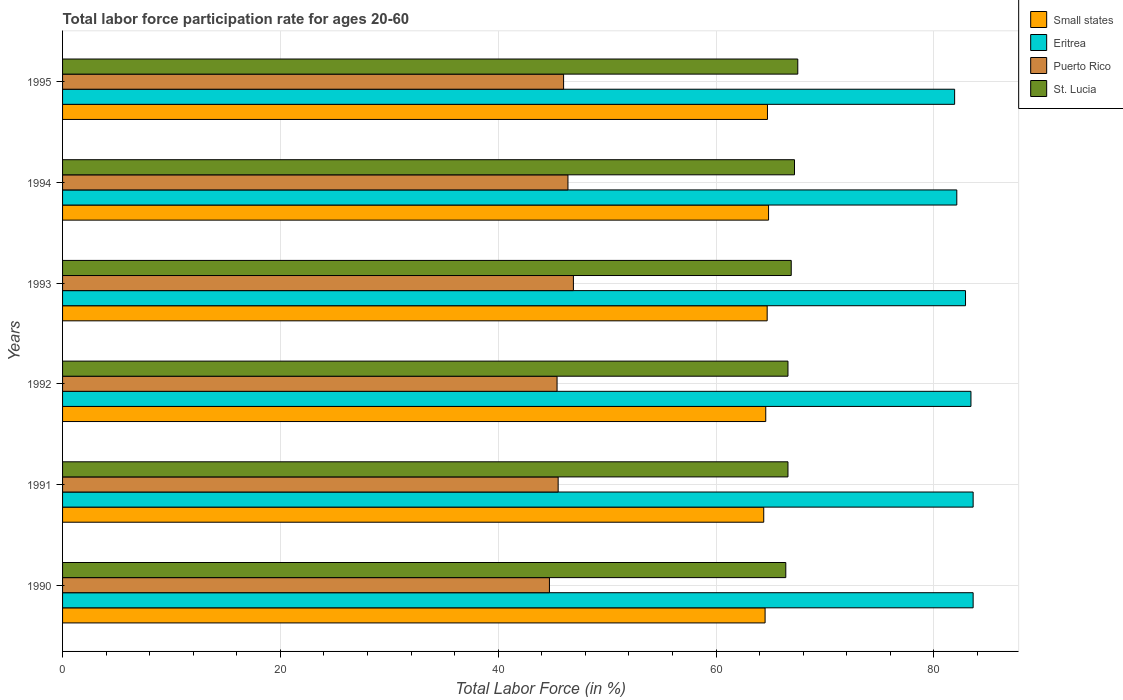How many different coloured bars are there?
Ensure brevity in your answer.  4. How many bars are there on the 4th tick from the top?
Provide a short and direct response. 4. In how many cases, is the number of bars for a given year not equal to the number of legend labels?
Provide a short and direct response. 0. What is the labor force participation rate in St. Lucia in 1993?
Ensure brevity in your answer.  66.9. Across all years, what is the maximum labor force participation rate in Puerto Rico?
Make the answer very short. 46.9. Across all years, what is the minimum labor force participation rate in Eritrea?
Offer a very short reply. 81.9. In which year was the labor force participation rate in St. Lucia maximum?
Your response must be concise. 1995. What is the total labor force participation rate in Puerto Rico in the graph?
Provide a succinct answer. 274.9. What is the difference between the labor force participation rate in Puerto Rico in 1993 and that in 1995?
Provide a short and direct response. 0.9. What is the difference between the labor force participation rate in Puerto Rico in 1993 and the labor force participation rate in Eritrea in 1994?
Your response must be concise. -35.2. What is the average labor force participation rate in Eritrea per year?
Make the answer very short. 82.92. In the year 1990, what is the difference between the labor force participation rate in St. Lucia and labor force participation rate in Puerto Rico?
Provide a short and direct response. 21.7. What is the ratio of the labor force participation rate in Puerto Rico in 1990 to that in 1995?
Offer a very short reply. 0.97. Is the labor force participation rate in Small states in 1991 less than that in 1993?
Offer a terse response. Yes. What is the difference between the highest and the lowest labor force participation rate in Eritrea?
Provide a short and direct response. 1.7. In how many years, is the labor force participation rate in Eritrea greater than the average labor force participation rate in Eritrea taken over all years?
Offer a very short reply. 3. Is the sum of the labor force participation rate in Puerto Rico in 1990 and 1994 greater than the maximum labor force participation rate in St. Lucia across all years?
Provide a succinct answer. Yes. What does the 4th bar from the top in 1995 represents?
Your answer should be compact. Small states. What does the 1st bar from the bottom in 1991 represents?
Give a very brief answer. Small states. Is it the case that in every year, the sum of the labor force participation rate in Small states and labor force participation rate in Eritrea is greater than the labor force participation rate in St. Lucia?
Make the answer very short. Yes. Are all the bars in the graph horizontal?
Ensure brevity in your answer.  Yes. How many years are there in the graph?
Offer a very short reply. 6. Are the values on the major ticks of X-axis written in scientific E-notation?
Offer a terse response. No. Does the graph contain any zero values?
Ensure brevity in your answer.  No. Does the graph contain grids?
Give a very brief answer. Yes. How are the legend labels stacked?
Your response must be concise. Vertical. What is the title of the graph?
Your answer should be compact. Total labor force participation rate for ages 20-60. What is the Total Labor Force (in %) of Small states in 1990?
Keep it short and to the point. 64.5. What is the Total Labor Force (in %) of Eritrea in 1990?
Provide a succinct answer. 83.6. What is the Total Labor Force (in %) in Puerto Rico in 1990?
Offer a very short reply. 44.7. What is the Total Labor Force (in %) in St. Lucia in 1990?
Offer a terse response. 66.4. What is the Total Labor Force (in %) in Small states in 1991?
Provide a succinct answer. 64.37. What is the Total Labor Force (in %) of Eritrea in 1991?
Your response must be concise. 83.6. What is the Total Labor Force (in %) in Puerto Rico in 1991?
Provide a succinct answer. 45.5. What is the Total Labor Force (in %) in St. Lucia in 1991?
Provide a short and direct response. 66.6. What is the Total Labor Force (in %) of Small states in 1992?
Give a very brief answer. 64.56. What is the Total Labor Force (in %) of Eritrea in 1992?
Give a very brief answer. 83.4. What is the Total Labor Force (in %) of Puerto Rico in 1992?
Offer a very short reply. 45.4. What is the Total Labor Force (in %) of St. Lucia in 1992?
Your answer should be compact. 66.6. What is the Total Labor Force (in %) of Small states in 1993?
Keep it short and to the point. 64.69. What is the Total Labor Force (in %) of Eritrea in 1993?
Ensure brevity in your answer.  82.9. What is the Total Labor Force (in %) in Puerto Rico in 1993?
Your response must be concise. 46.9. What is the Total Labor Force (in %) in St. Lucia in 1993?
Make the answer very short. 66.9. What is the Total Labor Force (in %) in Small states in 1994?
Give a very brief answer. 64.82. What is the Total Labor Force (in %) in Eritrea in 1994?
Make the answer very short. 82.1. What is the Total Labor Force (in %) in Puerto Rico in 1994?
Your response must be concise. 46.4. What is the Total Labor Force (in %) of St. Lucia in 1994?
Your answer should be compact. 67.2. What is the Total Labor Force (in %) in Small states in 1995?
Keep it short and to the point. 64.72. What is the Total Labor Force (in %) in Eritrea in 1995?
Keep it short and to the point. 81.9. What is the Total Labor Force (in %) in St. Lucia in 1995?
Offer a terse response. 67.5. Across all years, what is the maximum Total Labor Force (in %) in Small states?
Make the answer very short. 64.82. Across all years, what is the maximum Total Labor Force (in %) in Eritrea?
Keep it short and to the point. 83.6. Across all years, what is the maximum Total Labor Force (in %) in Puerto Rico?
Your response must be concise. 46.9. Across all years, what is the maximum Total Labor Force (in %) of St. Lucia?
Your answer should be very brief. 67.5. Across all years, what is the minimum Total Labor Force (in %) of Small states?
Your answer should be very brief. 64.37. Across all years, what is the minimum Total Labor Force (in %) in Eritrea?
Your answer should be very brief. 81.9. Across all years, what is the minimum Total Labor Force (in %) of Puerto Rico?
Your answer should be compact. 44.7. Across all years, what is the minimum Total Labor Force (in %) of St. Lucia?
Ensure brevity in your answer.  66.4. What is the total Total Labor Force (in %) of Small states in the graph?
Give a very brief answer. 387.66. What is the total Total Labor Force (in %) in Eritrea in the graph?
Offer a terse response. 497.5. What is the total Total Labor Force (in %) of Puerto Rico in the graph?
Offer a very short reply. 274.9. What is the total Total Labor Force (in %) of St. Lucia in the graph?
Offer a terse response. 401.2. What is the difference between the Total Labor Force (in %) of Small states in 1990 and that in 1991?
Keep it short and to the point. 0.12. What is the difference between the Total Labor Force (in %) of Puerto Rico in 1990 and that in 1991?
Keep it short and to the point. -0.8. What is the difference between the Total Labor Force (in %) of Small states in 1990 and that in 1992?
Provide a succinct answer. -0.06. What is the difference between the Total Labor Force (in %) of Eritrea in 1990 and that in 1992?
Your answer should be compact. 0.2. What is the difference between the Total Labor Force (in %) in Puerto Rico in 1990 and that in 1992?
Offer a very short reply. -0.7. What is the difference between the Total Labor Force (in %) in Small states in 1990 and that in 1993?
Provide a short and direct response. -0.19. What is the difference between the Total Labor Force (in %) in Eritrea in 1990 and that in 1993?
Provide a succinct answer. 0.7. What is the difference between the Total Labor Force (in %) of Puerto Rico in 1990 and that in 1993?
Provide a short and direct response. -2.2. What is the difference between the Total Labor Force (in %) of Small states in 1990 and that in 1994?
Ensure brevity in your answer.  -0.32. What is the difference between the Total Labor Force (in %) of St. Lucia in 1990 and that in 1994?
Offer a very short reply. -0.8. What is the difference between the Total Labor Force (in %) in Small states in 1990 and that in 1995?
Provide a short and direct response. -0.22. What is the difference between the Total Labor Force (in %) in Puerto Rico in 1990 and that in 1995?
Provide a succinct answer. -1.3. What is the difference between the Total Labor Force (in %) of Small states in 1991 and that in 1992?
Offer a terse response. -0.19. What is the difference between the Total Labor Force (in %) in Eritrea in 1991 and that in 1992?
Your answer should be very brief. 0.2. What is the difference between the Total Labor Force (in %) of St. Lucia in 1991 and that in 1992?
Your answer should be compact. 0. What is the difference between the Total Labor Force (in %) of Small states in 1991 and that in 1993?
Provide a succinct answer. -0.32. What is the difference between the Total Labor Force (in %) of St. Lucia in 1991 and that in 1993?
Your answer should be compact. -0.3. What is the difference between the Total Labor Force (in %) in Small states in 1991 and that in 1994?
Ensure brevity in your answer.  -0.44. What is the difference between the Total Labor Force (in %) in Eritrea in 1991 and that in 1994?
Your answer should be very brief. 1.5. What is the difference between the Total Labor Force (in %) of Small states in 1991 and that in 1995?
Give a very brief answer. -0.34. What is the difference between the Total Labor Force (in %) of Eritrea in 1991 and that in 1995?
Ensure brevity in your answer.  1.7. What is the difference between the Total Labor Force (in %) in Puerto Rico in 1991 and that in 1995?
Ensure brevity in your answer.  -0.5. What is the difference between the Total Labor Force (in %) of Small states in 1992 and that in 1993?
Your response must be concise. -0.13. What is the difference between the Total Labor Force (in %) of Eritrea in 1992 and that in 1993?
Make the answer very short. 0.5. What is the difference between the Total Labor Force (in %) of Puerto Rico in 1992 and that in 1993?
Offer a terse response. -1.5. What is the difference between the Total Labor Force (in %) of Small states in 1992 and that in 1994?
Provide a succinct answer. -0.26. What is the difference between the Total Labor Force (in %) in Puerto Rico in 1992 and that in 1994?
Your answer should be compact. -1. What is the difference between the Total Labor Force (in %) in St. Lucia in 1992 and that in 1994?
Ensure brevity in your answer.  -0.6. What is the difference between the Total Labor Force (in %) of Small states in 1992 and that in 1995?
Provide a succinct answer. -0.16. What is the difference between the Total Labor Force (in %) in Eritrea in 1992 and that in 1995?
Offer a very short reply. 1.5. What is the difference between the Total Labor Force (in %) of Puerto Rico in 1992 and that in 1995?
Offer a very short reply. -0.6. What is the difference between the Total Labor Force (in %) in Small states in 1993 and that in 1994?
Your response must be concise. -0.13. What is the difference between the Total Labor Force (in %) of Eritrea in 1993 and that in 1994?
Your answer should be very brief. 0.8. What is the difference between the Total Labor Force (in %) of Small states in 1993 and that in 1995?
Provide a short and direct response. -0.03. What is the difference between the Total Labor Force (in %) in Eritrea in 1993 and that in 1995?
Keep it short and to the point. 1. What is the difference between the Total Labor Force (in %) in Puerto Rico in 1993 and that in 1995?
Provide a succinct answer. 0.9. What is the difference between the Total Labor Force (in %) of Small states in 1994 and that in 1995?
Your response must be concise. 0.1. What is the difference between the Total Labor Force (in %) of Eritrea in 1994 and that in 1995?
Provide a succinct answer. 0.2. What is the difference between the Total Labor Force (in %) in Puerto Rico in 1994 and that in 1995?
Offer a terse response. 0.4. What is the difference between the Total Labor Force (in %) of Small states in 1990 and the Total Labor Force (in %) of Eritrea in 1991?
Your response must be concise. -19.1. What is the difference between the Total Labor Force (in %) of Small states in 1990 and the Total Labor Force (in %) of Puerto Rico in 1991?
Provide a succinct answer. 19. What is the difference between the Total Labor Force (in %) in Small states in 1990 and the Total Labor Force (in %) in St. Lucia in 1991?
Provide a succinct answer. -2.1. What is the difference between the Total Labor Force (in %) of Eritrea in 1990 and the Total Labor Force (in %) of Puerto Rico in 1991?
Your response must be concise. 38.1. What is the difference between the Total Labor Force (in %) in Puerto Rico in 1990 and the Total Labor Force (in %) in St. Lucia in 1991?
Offer a terse response. -21.9. What is the difference between the Total Labor Force (in %) of Small states in 1990 and the Total Labor Force (in %) of Eritrea in 1992?
Give a very brief answer. -18.9. What is the difference between the Total Labor Force (in %) of Small states in 1990 and the Total Labor Force (in %) of Puerto Rico in 1992?
Give a very brief answer. 19.1. What is the difference between the Total Labor Force (in %) in Small states in 1990 and the Total Labor Force (in %) in St. Lucia in 1992?
Provide a short and direct response. -2.1. What is the difference between the Total Labor Force (in %) in Eritrea in 1990 and the Total Labor Force (in %) in Puerto Rico in 1992?
Provide a short and direct response. 38.2. What is the difference between the Total Labor Force (in %) of Eritrea in 1990 and the Total Labor Force (in %) of St. Lucia in 1992?
Your answer should be compact. 17. What is the difference between the Total Labor Force (in %) in Puerto Rico in 1990 and the Total Labor Force (in %) in St. Lucia in 1992?
Keep it short and to the point. -21.9. What is the difference between the Total Labor Force (in %) in Small states in 1990 and the Total Labor Force (in %) in Eritrea in 1993?
Give a very brief answer. -18.4. What is the difference between the Total Labor Force (in %) of Small states in 1990 and the Total Labor Force (in %) of Puerto Rico in 1993?
Keep it short and to the point. 17.6. What is the difference between the Total Labor Force (in %) of Small states in 1990 and the Total Labor Force (in %) of St. Lucia in 1993?
Your response must be concise. -2.4. What is the difference between the Total Labor Force (in %) of Eritrea in 1990 and the Total Labor Force (in %) of Puerto Rico in 1993?
Provide a short and direct response. 36.7. What is the difference between the Total Labor Force (in %) of Eritrea in 1990 and the Total Labor Force (in %) of St. Lucia in 1993?
Make the answer very short. 16.7. What is the difference between the Total Labor Force (in %) of Puerto Rico in 1990 and the Total Labor Force (in %) of St. Lucia in 1993?
Make the answer very short. -22.2. What is the difference between the Total Labor Force (in %) of Small states in 1990 and the Total Labor Force (in %) of Eritrea in 1994?
Make the answer very short. -17.6. What is the difference between the Total Labor Force (in %) of Small states in 1990 and the Total Labor Force (in %) of Puerto Rico in 1994?
Your response must be concise. 18.1. What is the difference between the Total Labor Force (in %) in Small states in 1990 and the Total Labor Force (in %) in St. Lucia in 1994?
Offer a very short reply. -2.7. What is the difference between the Total Labor Force (in %) in Eritrea in 1990 and the Total Labor Force (in %) in Puerto Rico in 1994?
Your answer should be compact. 37.2. What is the difference between the Total Labor Force (in %) of Eritrea in 1990 and the Total Labor Force (in %) of St. Lucia in 1994?
Make the answer very short. 16.4. What is the difference between the Total Labor Force (in %) of Puerto Rico in 1990 and the Total Labor Force (in %) of St. Lucia in 1994?
Provide a short and direct response. -22.5. What is the difference between the Total Labor Force (in %) of Small states in 1990 and the Total Labor Force (in %) of Eritrea in 1995?
Give a very brief answer. -17.4. What is the difference between the Total Labor Force (in %) in Small states in 1990 and the Total Labor Force (in %) in Puerto Rico in 1995?
Offer a very short reply. 18.5. What is the difference between the Total Labor Force (in %) of Small states in 1990 and the Total Labor Force (in %) of St. Lucia in 1995?
Your response must be concise. -3. What is the difference between the Total Labor Force (in %) in Eritrea in 1990 and the Total Labor Force (in %) in Puerto Rico in 1995?
Offer a terse response. 37.6. What is the difference between the Total Labor Force (in %) in Puerto Rico in 1990 and the Total Labor Force (in %) in St. Lucia in 1995?
Your answer should be compact. -22.8. What is the difference between the Total Labor Force (in %) of Small states in 1991 and the Total Labor Force (in %) of Eritrea in 1992?
Your response must be concise. -19.03. What is the difference between the Total Labor Force (in %) of Small states in 1991 and the Total Labor Force (in %) of Puerto Rico in 1992?
Offer a terse response. 18.97. What is the difference between the Total Labor Force (in %) in Small states in 1991 and the Total Labor Force (in %) in St. Lucia in 1992?
Ensure brevity in your answer.  -2.23. What is the difference between the Total Labor Force (in %) of Eritrea in 1991 and the Total Labor Force (in %) of Puerto Rico in 1992?
Ensure brevity in your answer.  38.2. What is the difference between the Total Labor Force (in %) in Eritrea in 1991 and the Total Labor Force (in %) in St. Lucia in 1992?
Make the answer very short. 17. What is the difference between the Total Labor Force (in %) of Puerto Rico in 1991 and the Total Labor Force (in %) of St. Lucia in 1992?
Your answer should be compact. -21.1. What is the difference between the Total Labor Force (in %) in Small states in 1991 and the Total Labor Force (in %) in Eritrea in 1993?
Offer a very short reply. -18.53. What is the difference between the Total Labor Force (in %) in Small states in 1991 and the Total Labor Force (in %) in Puerto Rico in 1993?
Your answer should be compact. 17.47. What is the difference between the Total Labor Force (in %) of Small states in 1991 and the Total Labor Force (in %) of St. Lucia in 1993?
Make the answer very short. -2.53. What is the difference between the Total Labor Force (in %) of Eritrea in 1991 and the Total Labor Force (in %) of Puerto Rico in 1993?
Give a very brief answer. 36.7. What is the difference between the Total Labor Force (in %) in Eritrea in 1991 and the Total Labor Force (in %) in St. Lucia in 1993?
Provide a succinct answer. 16.7. What is the difference between the Total Labor Force (in %) of Puerto Rico in 1991 and the Total Labor Force (in %) of St. Lucia in 1993?
Offer a very short reply. -21.4. What is the difference between the Total Labor Force (in %) in Small states in 1991 and the Total Labor Force (in %) in Eritrea in 1994?
Give a very brief answer. -17.73. What is the difference between the Total Labor Force (in %) of Small states in 1991 and the Total Labor Force (in %) of Puerto Rico in 1994?
Your answer should be compact. 17.97. What is the difference between the Total Labor Force (in %) of Small states in 1991 and the Total Labor Force (in %) of St. Lucia in 1994?
Provide a short and direct response. -2.83. What is the difference between the Total Labor Force (in %) of Eritrea in 1991 and the Total Labor Force (in %) of Puerto Rico in 1994?
Offer a terse response. 37.2. What is the difference between the Total Labor Force (in %) of Eritrea in 1991 and the Total Labor Force (in %) of St. Lucia in 1994?
Provide a short and direct response. 16.4. What is the difference between the Total Labor Force (in %) in Puerto Rico in 1991 and the Total Labor Force (in %) in St. Lucia in 1994?
Give a very brief answer. -21.7. What is the difference between the Total Labor Force (in %) of Small states in 1991 and the Total Labor Force (in %) of Eritrea in 1995?
Provide a short and direct response. -17.53. What is the difference between the Total Labor Force (in %) of Small states in 1991 and the Total Labor Force (in %) of Puerto Rico in 1995?
Your answer should be compact. 18.37. What is the difference between the Total Labor Force (in %) in Small states in 1991 and the Total Labor Force (in %) in St. Lucia in 1995?
Ensure brevity in your answer.  -3.13. What is the difference between the Total Labor Force (in %) of Eritrea in 1991 and the Total Labor Force (in %) of Puerto Rico in 1995?
Your answer should be compact. 37.6. What is the difference between the Total Labor Force (in %) of Eritrea in 1991 and the Total Labor Force (in %) of St. Lucia in 1995?
Provide a short and direct response. 16.1. What is the difference between the Total Labor Force (in %) of Puerto Rico in 1991 and the Total Labor Force (in %) of St. Lucia in 1995?
Keep it short and to the point. -22. What is the difference between the Total Labor Force (in %) in Small states in 1992 and the Total Labor Force (in %) in Eritrea in 1993?
Your answer should be very brief. -18.34. What is the difference between the Total Labor Force (in %) of Small states in 1992 and the Total Labor Force (in %) of Puerto Rico in 1993?
Provide a short and direct response. 17.66. What is the difference between the Total Labor Force (in %) of Small states in 1992 and the Total Labor Force (in %) of St. Lucia in 1993?
Provide a short and direct response. -2.34. What is the difference between the Total Labor Force (in %) of Eritrea in 1992 and the Total Labor Force (in %) of Puerto Rico in 1993?
Ensure brevity in your answer.  36.5. What is the difference between the Total Labor Force (in %) of Eritrea in 1992 and the Total Labor Force (in %) of St. Lucia in 1993?
Provide a succinct answer. 16.5. What is the difference between the Total Labor Force (in %) of Puerto Rico in 1992 and the Total Labor Force (in %) of St. Lucia in 1993?
Offer a very short reply. -21.5. What is the difference between the Total Labor Force (in %) of Small states in 1992 and the Total Labor Force (in %) of Eritrea in 1994?
Make the answer very short. -17.54. What is the difference between the Total Labor Force (in %) in Small states in 1992 and the Total Labor Force (in %) in Puerto Rico in 1994?
Your answer should be compact. 18.16. What is the difference between the Total Labor Force (in %) in Small states in 1992 and the Total Labor Force (in %) in St. Lucia in 1994?
Offer a terse response. -2.64. What is the difference between the Total Labor Force (in %) in Eritrea in 1992 and the Total Labor Force (in %) in Puerto Rico in 1994?
Ensure brevity in your answer.  37. What is the difference between the Total Labor Force (in %) of Puerto Rico in 1992 and the Total Labor Force (in %) of St. Lucia in 1994?
Your answer should be very brief. -21.8. What is the difference between the Total Labor Force (in %) of Small states in 1992 and the Total Labor Force (in %) of Eritrea in 1995?
Provide a short and direct response. -17.34. What is the difference between the Total Labor Force (in %) of Small states in 1992 and the Total Labor Force (in %) of Puerto Rico in 1995?
Provide a short and direct response. 18.56. What is the difference between the Total Labor Force (in %) in Small states in 1992 and the Total Labor Force (in %) in St. Lucia in 1995?
Offer a very short reply. -2.94. What is the difference between the Total Labor Force (in %) in Eritrea in 1992 and the Total Labor Force (in %) in Puerto Rico in 1995?
Give a very brief answer. 37.4. What is the difference between the Total Labor Force (in %) of Eritrea in 1992 and the Total Labor Force (in %) of St. Lucia in 1995?
Offer a terse response. 15.9. What is the difference between the Total Labor Force (in %) of Puerto Rico in 1992 and the Total Labor Force (in %) of St. Lucia in 1995?
Your response must be concise. -22.1. What is the difference between the Total Labor Force (in %) in Small states in 1993 and the Total Labor Force (in %) in Eritrea in 1994?
Your response must be concise. -17.41. What is the difference between the Total Labor Force (in %) in Small states in 1993 and the Total Labor Force (in %) in Puerto Rico in 1994?
Ensure brevity in your answer.  18.29. What is the difference between the Total Labor Force (in %) in Small states in 1993 and the Total Labor Force (in %) in St. Lucia in 1994?
Keep it short and to the point. -2.51. What is the difference between the Total Labor Force (in %) in Eritrea in 1993 and the Total Labor Force (in %) in Puerto Rico in 1994?
Your answer should be very brief. 36.5. What is the difference between the Total Labor Force (in %) in Puerto Rico in 1993 and the Total Labor Force (in %) in St. Lucia in 1994?
Your answer should be compact. -20.3. What is the difference between the Total Labor Force (in %) of Small states in 1993 and the Total Labor Force (in %) of Eritrea in 1995?
Provide a short and direct response. -17.21. What is the difference between the Total Labor Force (in %) in Small states in 1993 and the Total Labor Force (in %) in Puerto Rico in 1995?
Your answer should be very brief. 18.69. What is the difference between the Total Labor Force (in %) of Small states in 1993 and the Total Labor Force (in %) of St. Lucia in 1995?
Offer a terse response. -2.81. What is the difference between the Total Labor Force (in %) of Eritrea in 1993 and the Total Labor Force (in %) of Puerto Rico in 1995?
Your answer should be very brief. 36.9. What is the difference between the Total Labor Force (in %) in Eritrea in 1993 and the Total Labor Force (in %) in St. Lucia in 1995?
Make the answer very short. 15.4. What is the difference between the Total Labor Force (in %) in Puerto Rico in 1993 and the Total Labor Force (in %) in St. Lucia in 1995?
Give a very brief answer. -20.6. What is the difference between the Total Labor Force (in %) of Small states in 1994 and the Total Labor Force (in %) of Eritrea in 1995?
Keep it short and to the point. -17.08. What is the difference between the Total Labor Force (in %) of Small states in 1994 and the Total Labor Force (in %) of Puerto Rico in 1995?
Offer a very short reply. 18.82. What is the difference between the Total Labor Force (in %) in Small states in 1994 and the Total Labor Force (in %) in St. Lucia in 1995?
Provide a short and direct response. -2.68. What is the difference between the Total Labor Force (in %) of Eritrea in 1994 and the Total Labor Force (in %) of Puerto Rico in 1995?
Provide a short and direct response. 36.1. What is the difference between the Total Labor Force (in %) of Eritrea in 1994 and the Total Labor Force (in %) of St. Lucia in 1995?
Provide a succinct answer. 14.6. What is the difference between the Total Labor Force (in %) of Puerto Rico in 1994 and the Total Labor Force (in %) of St. Lucia in 1995?
Your answer should be very brief. -21.1. What is the average Total Labor Force (in %) of Small states per year?
Ensure brevity in your answer.  64.61. What is the average Total Labor Force (in %) in Eritrea per year?
Offer a very short reply. 82.92. What is the average Total Labor Force (in %) in Puerto Rico per year?
Make the answer very short. 45.82. What is the average Total Labor Force (in %) of St. Lucia per year?
Keep it short and to the point. 66.87. In the year 1990, what is the difference between the Total Labor Force (in %) of Small states and Total Labor Force (in %) of Eritrea?
Offer a terse response. -19.1. In the year 1990, what is the difference between the Total Labor Force (in %) of Small states and Total Labor Force (in %) of Puerto Rico?
Your response must be concise. 19.8. In the year 1990, what is the difference between the Total Labor Force (in %) in Small states and Total Labor Force (in %) in St. Lucia?
Offer a very short reply. -1.9. In the year 1990, what is the difference between the Total Labor Force (in %) of Eritrea and Total Labor Force (in %) of Puerto Rico?
Keep it short and to the point. 38.9. In the year 1990, what is the difference between the Total Labor Force (in %) of Eritrea and Total Labor Force (in %) of St. Lucia?
Your answer should be compact. 17.2. In the year 1990, what is the difference between the Total Labor Force (in %) of Puerto Rico and Total Labor Force (in %) of St. Lucia?
Ensure brevity in your answer.  -21.7. In the year 1991, what is the difference between the Total Labor Force (in %) in Small states and Total Labor Force (in %) in Eritrea?
Your response must be concise. -19.23. In the year 1991, what is the difference between the Total Labor Force (in %) in Small states and Total Labor Force (in %) in Puerto Rico?
Make the answer very short. 18.87. In the year 1991, what is the difference between the Total Labor Force (in %) in Small states and Total Labor Force (in %) in St. Lucia?
Keep it short and to the point. -2.23. In the year 1991, what is the difference between the Total Labor Force (in %) of Eritrea and Total Labor Force (in %) of Puerto Rico?
Provide a short and direct response. 38.1. In the year 1991, what is the difference between the Total Labor Force (in %) of Eritrea and Total Labor Force (in %) of St. Lucia?
Offer a very short reply. 17. In the year 1991, what is the difference between the Total Labor Force (in %) of Puerto Rico and Total Labor Force (in %) of St. Lucia?
Your answer should be compact. -21.1. In the year 1992, what is the difference between the Total Labor Force (in %) in Small states and Total Labor Force (in %) in Eritrea?
Ensure brevity in your answer.  -18.84. In the year 1992, what is the difference between the Total Labor Force (in %) in Small states and Total Labor Force (in %) in Puerto Rico?
Offer a very short reply. 19.16. In the year 1992, what is the difference between the Total Labor Force (in %) of Small states and Total Labor Force (in %) of St. Lucia?
Your answer should be very brief. -2.04. In the year 1992, what is the difference between the Total Labor Force (in %) of Puerto Rico and Total Labor Force (in %) of St. Lucia?
Ensure brevity in your answer.  -21.2. In the year 1993, what is the difference between the Total Labor Force (in %) of Small states and Total Labor Force (in %) of Eritrea?
Keep it short and to the point. -18.21. In the year 1993, what is the difference between the Total Labor Force (in %) in Small states and Total Labor Force (in %) in Puerto Rico?
Make the answer very short. 17.79. In the year 1993, what is the difference between the Total Labor Force (in %) of Small states and Total Labor Force (in %) of St. Lucia?
Provide a succinct answer. -2.21. In the year 1993, what is the difference between the Total Labor Force (in %) in Eritrea and Total Labor Force (in %) in Puerto Rico?
Provide a short and direct response. 36. In the year 1993, what is the difference between the Total Labor Force (in %) of Puerto Rico and Total Labor Force (in %) of St. Lucia?
Offer a very short reply. -20. In the year 1994, what is the difference between the Total Labor Force (in %) of Small states and Total Labor Force (in %) of Eritrea?
Offer a terse response. -17.28. In the year 1994, what is the difference between the Total Labor Force (in %) of Small states and Total Labor Force (in %) of Puerto Rico?
Your answer should be compact. 18.42. In the year 1994, what is the difference between the Total Labor Force (in %) in Small states and Total Labor Force (in %) in St. Lucia?
Provide a short and direct response. -2.38. In the year 1994, what is the difference between the Total Labor Force (in %) in Eritrea and Total Labor Force (in %) in Puerto Rico?
Your answer should be very brief. 35.7. In the year 1994, what is the difference between the Total Labor Force (in %) in Puerto Rico and Total Labor Force (in %) in St. Lucia?
Provide a short and direct response. -20.8. In the year 1995, what is the difference between the Total Labor Force (in %) in Small states and Total Labor Force (in %) in Eritrea?
Offer a terse response. -17.18. In the year 1995, what is the difference between the Total Labor Force (in %) of Small states and Total Labor Force (in %) of Puerto Rico?
Give a very brief answer. 18.72. In the year 1995, what is the difference between the Total Labor Force (in %) of Small states and Total Labor Force (in %) of St. Lucia?
Offer a very short reply. -2.78. In the year 1995, what is the difference between the Total Labor Force (in %) of Eritrea and Total Labor Force (in %) of Puerto Rico?
Provide a succinct answer. 35.9. In the year 1995, what is the difference between the Total Labor Force (in %) of Eritrea and Total Labor Force (in %) of St. Lucia?
Offer a terse response. 14.4. In the year 1995, what is the difference between the Total Labor Force (in %) in Puerto Rico and Total Labor Force (in %) in St. Lucia?
Make the answer very short. -21.5. What is the ratio of the Total Labor Force (in %) in Small states in 1990 to that in 1991?
Provide a short and direct response. 1. What is the ratio of the Total Labor Force (in %) in Puerto Rico in 1990 to that in 1991?
Provide a short and direct response. 0.98. What is the ratio of the Total Labor Force (in %) in St. Lucia in 1990 to that in 1991?
Give a very brief answer. 1. What is the ratio of the Total Labor Force (in %) in Eritrea in 1990 to that in 1992?
Keep it short and to the point. 1. What is the ratio of the Total Labor Force (in %) in Puerto Rico in 1990 to that in 1992?
Your answer should be compact. 0.98. What is the ratio of the Total Labor Force (in %) in Small states in 1990 to that in 1993?
Your answer should be very brief. 1. What is the ratio of the Total Labor Force (in %) in Eritrea in 1990 to that in 1993?
Offer a very short reply. 1.01. What is the ratio of the Total Labor Force (in %) in Puerto Rico in 1990 to that in 1993?
Offer a terse response. 0.95. What is the ratio of the Total Labor Force (in %) in St. Lucia in 1990 to that in 1993?
Ensure brevity in your answer.  0.99. What is the ratio of the Total Labor Force (in %) in Small states in 1990 to that in 1994?
Make the answer very short. 1. What is the ratio of the Total Labor Force (in %) of Eritrea in 1990 to that in 1994?
Make the answer very short. 1.02. What is the ratio of the Total Labor Force (in %) in Puerto Rico in 1990 to that in 1994?
Keep it short and to the point. 0.96. What is the ratio of the Total Labor Force (in %) of St. Lucia in 1990 to that in 1994?
Provide a short and direct response. 0.99. What is the ratio of the Total Labor Force (in %) of Small states in 1990 to that in 1995?
Make the answer very short. 1. What is the ratio of the Total Labor Force (in %) of Eritrea in 1990 to that in 1995?
Offer a terse response. 1.02. What is the ratio of the Total Labor Force (in %) in Puerto Rico in 1990 to that in 1995?
Your answer should be compact. 0.97. What is the ratio of the Total Labor Force (in %) in St. Lucia in 1990 to that in 1995?
Give a very brief answer. 0.98. What is the ratio of the Total Labor Force (in %) in Puerto Rico in 1991 to that in 1992?
Your answer should be very brief. 1. What is the ratio of the Total Labor Force (in %) in St. Lucia in 1991 to that in 1992?
Give a very brief answer. 1. What is the ratio of the Total Labor Force (in %) in Eritrea in 1991 to that in 1993?
Offer a terse response. 1.01. What is the ratio of the Total Labor Force (in %) in Puerto Rico in 1991 to that in 1993?
Provide a succinct answer. 0.97. What is the ratio of the Total Labor Force (in %) in Small states in 1991 to that in 1994?
Make the answer very short. 0.99. What is the ratio of the Total Labor Force (in %) of Eritrea in 1991 to that in 1994?
Keep it short and to the point. 1.02. What is the ratio of the Total Labor Force (in %) of Puerto Rico in 1991 to that in 1994?
Provide a succinct answer. 0.98. What is the ratio of the Total Labor Force (in %) in Small states in 1991 to that in 1995?
Give a very brief answer. 0.99. What is the ratio of the Total Labor Force (in %) of Eritrea in 1991 to that in 1995?
Your answer should be compact. 1.02. What is the ratio of the Total Labor Force (in %) in St. Lucia in 1991 to that in 1995?
Ensure brevity in your answer.  0.99. What is the ratio of the Total Labor Force (in %) of St. Lucia in 1992 to that in 1993?
Provide a short and direct response. 1. What is the ratio of the Total Labor Force (in %) of Small states in 1992 to that in 1994?
Provide a short and direct response. 1. What is the ratio of the Total Labor Force (in %) of Eritrea in 1992 to that in 1994?
Make the answer very short. 1.02. What is the ratio of the Total Labor Force (in %) of Puerto Rico in 1992 to that in 1994?
Offer a terse response. 0.98. What is the ratio of the Total Labor Force (in %) of St. Lucia in 1992 to that in 1994?
Your answer should be very brief. 0.99. What is the ratio of the Total Labor Force (in %) in Small states in 1992 to that in 1995?
Make the answer very short. 1. What is the ratio of the Total Labor Force (in %) in Eritrea in 1992 to that in 1995?
Provide a succinct answer. 1.02. What is the ratio of the Total Labor Force (in %) of Puerto Rico in 1992 to that in 1995?
Your response must be concise. 0.99. What is the ratio of the Total Labor Force (in %) of St. Lucia in 1992 to that in 1995?
Make the answer very short. 0.99. What is the ratio of the Total Labor Force (in %) of Small states in 1993 to that in 1994?
Give a very brief answer. 1. What is the ratio of the Total Labor Force (in %) of Eritrea in 1993 to that in 1994?
Provide a short and direct response. 1.01. What is the ratio of the Total Labor Force (in %) of Puerto Rico in 1993 to that in 1994?
Your response must be concise. 1.01. What is the ratio of the Total Labor Force (in %) of Eritrea in 1993 to that in 1995?
Offer a very short reply. 1.01. What is the ratio of the Total Labor Force (in %) of Puerto Rico in 1993 to that in 1995?
Offer a terse response. 1.02. What is the ratio of the Total Labor Force (in %) in St. Lucia in 1993 to that in 1995?
Ensure brevity in your answer.  0.99. What is the ratio of the Total Labor Force (in %) in Eritrea in 1994 to that in 1995?
Offer a very short reply. 1. What is the ratio of the Total Labor Force (in %) of Puerto Rico in 1994 to that in 1995?
Ensure brevity in your answer.  1.01. What is the difference between the highest and the second highest Total Labor Force (in %) of Small states?
Give a very brief answer. 0.1. What is the difference between the highest and the second highest Total Labor Force (in %) in Eritrea?
Provide a short and direct response. 0. What is the difference between the highest and the lowest Total Labor Force (in %) in Small states?
Make the answer very short. 0.44. What is the difference between the highest and the lowest Total Labor Force (in %) of Puerto Rico?
Provide a succinct answer. 2.2. What is the difference between the highest and the lowest Total Labor Force (in %) in St. Lucia?
Offer a very short reply. 1.1. 